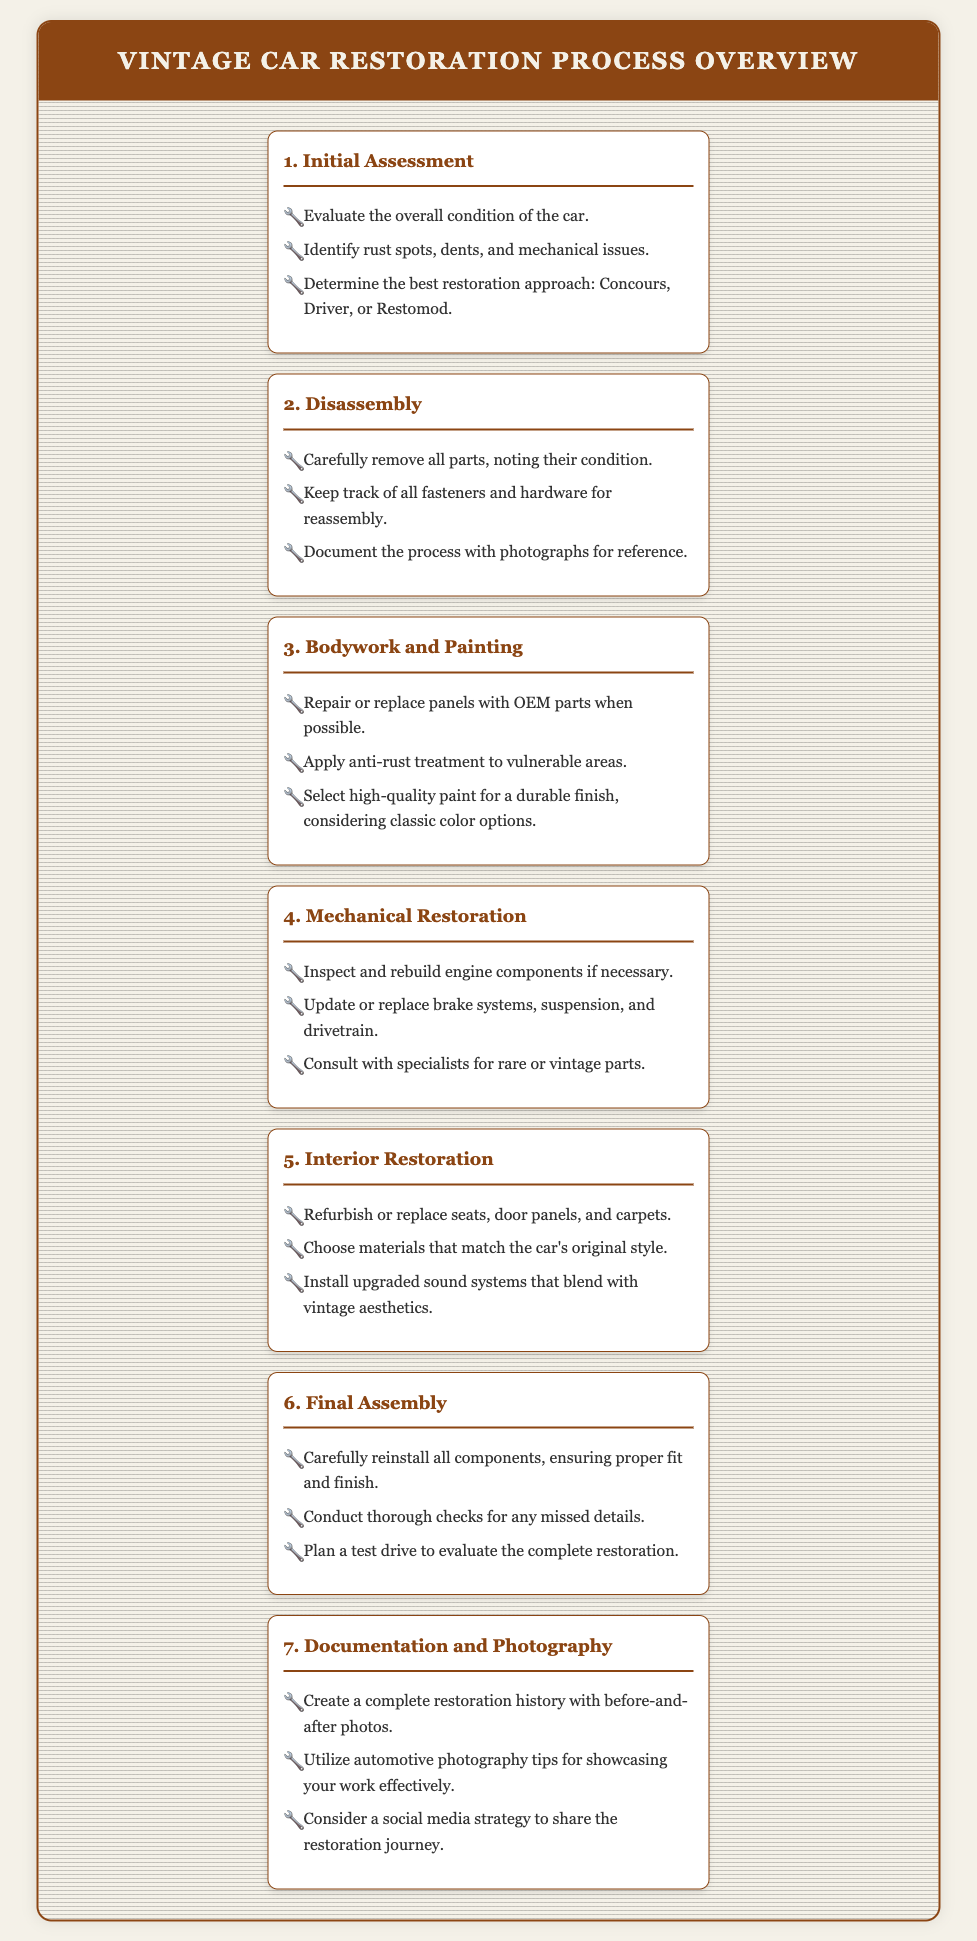What is the first step in the restoration process? The first step is "Initial Assessment," which evaluates the overall condition of the car.
Answer: Initial Assessment How many main steps are listed in the restoration process? There are seven main steps outlined in the document.
Answer: 7 What should be documented during disassembly? The process should be documented with photographs for reference.
Answer: Photographs Which phase focuses on the car's interior? The phase that focuses on the car's interior is "Interior Restoration."
Answer: Interior Restoration What type of parts should be used for bodywork? OEM parts should be used for bodywork when possible.
Answer: OEM parts Which restoration approach involves updating features? The "Restomod" approach involves updating features while maintaining vintage aesthetics.
Answer: Restomod What is recommended to ensure proper fit and finish during final assembly? It is recommended to carefully reinstall all components.
Answer: Carefully reinstall What should be created to showcase the restoration? A complete restoration history with before-and-after photos should be created.
Answer: Restoration history 